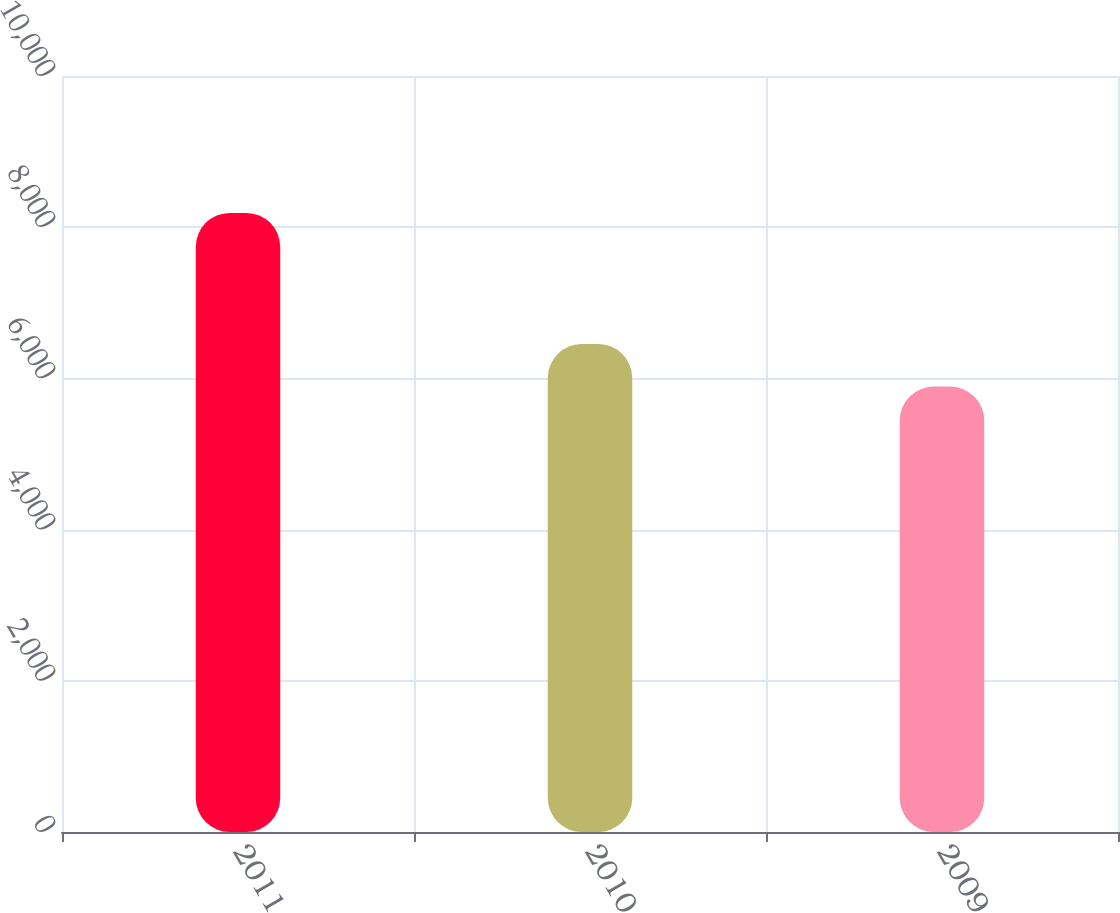Convert chart to OTSL. <chart><loc_0><loc_0><loc_500><loc_500><bar_chart><fcel>2011<fcel>2010<fcel>2009<nl><fcel>8189<fcel>6455<fcel>5892<nl></chart> 